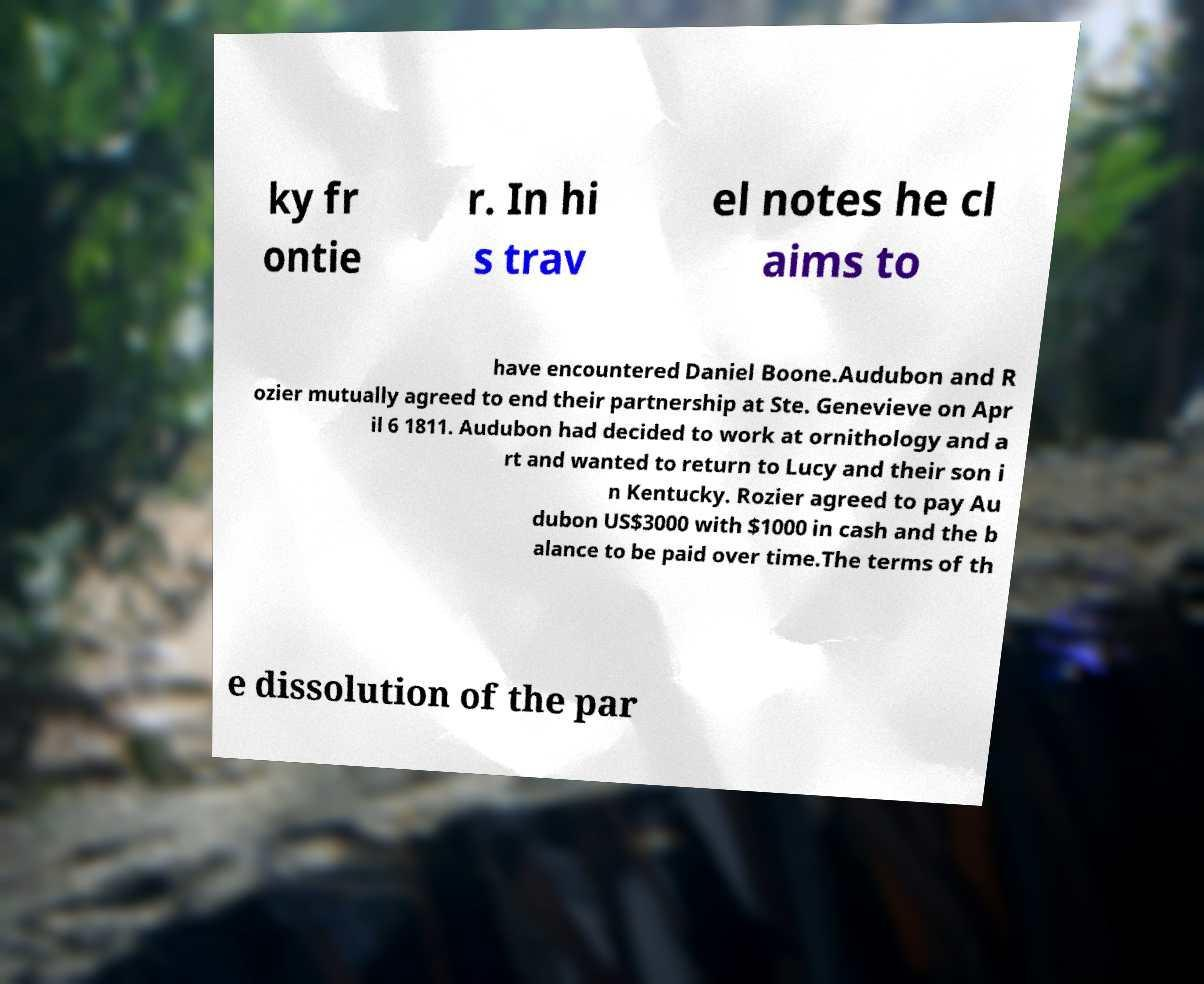Can you accurately transcribe the text from the provided image for me? ky fr ontie r. In hi s trav el notes he cl aims to have encountered Daniel Boone.Audubon and R ozier mutually agreed to end their partnership at Ste. Genevieve on Apr il 6 1811. Audubon had decided to work at ornithology and a rt and wanted to return to Lucy and their son i n Kentucky. Rozier agreed to pay Au dubon US$3000 with $1000 in cash and the b alance to be paid over time.The terms of th e dissolution of the par 